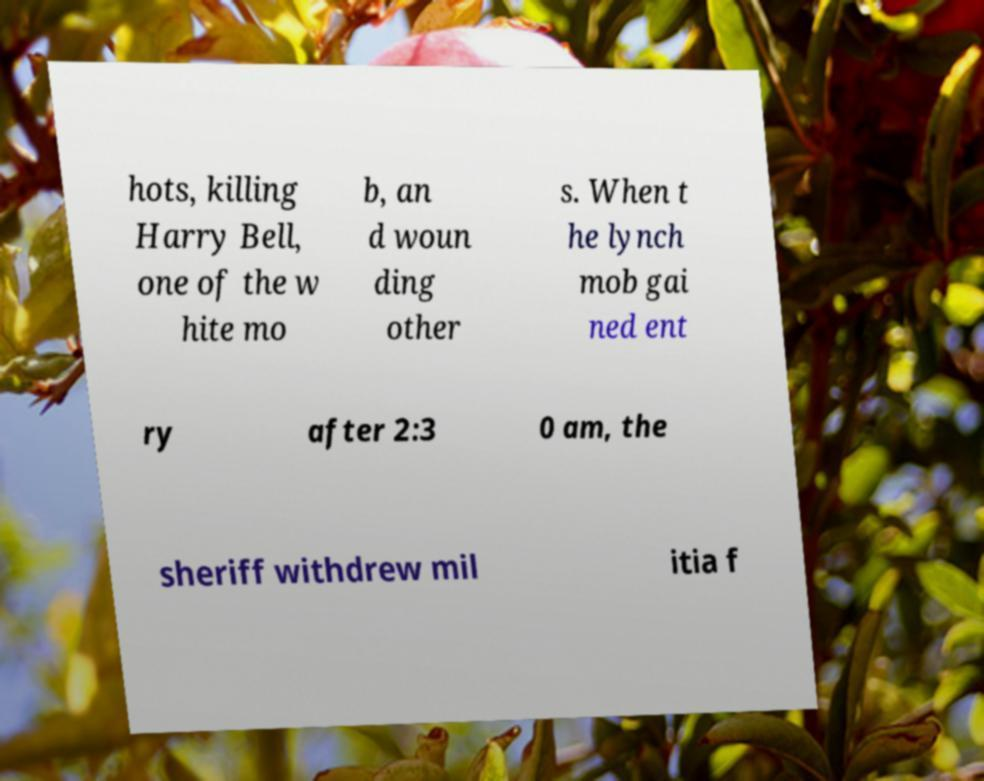What messages or text are displayed in this image? I need them in a readable, typed format. hots, killing Harry Bell, one of the w hite mo b, an d woun ding other s. When t he lynch mob gai ned ent ry after 2:3 0 am, the sheriff withdrew mil itia f 